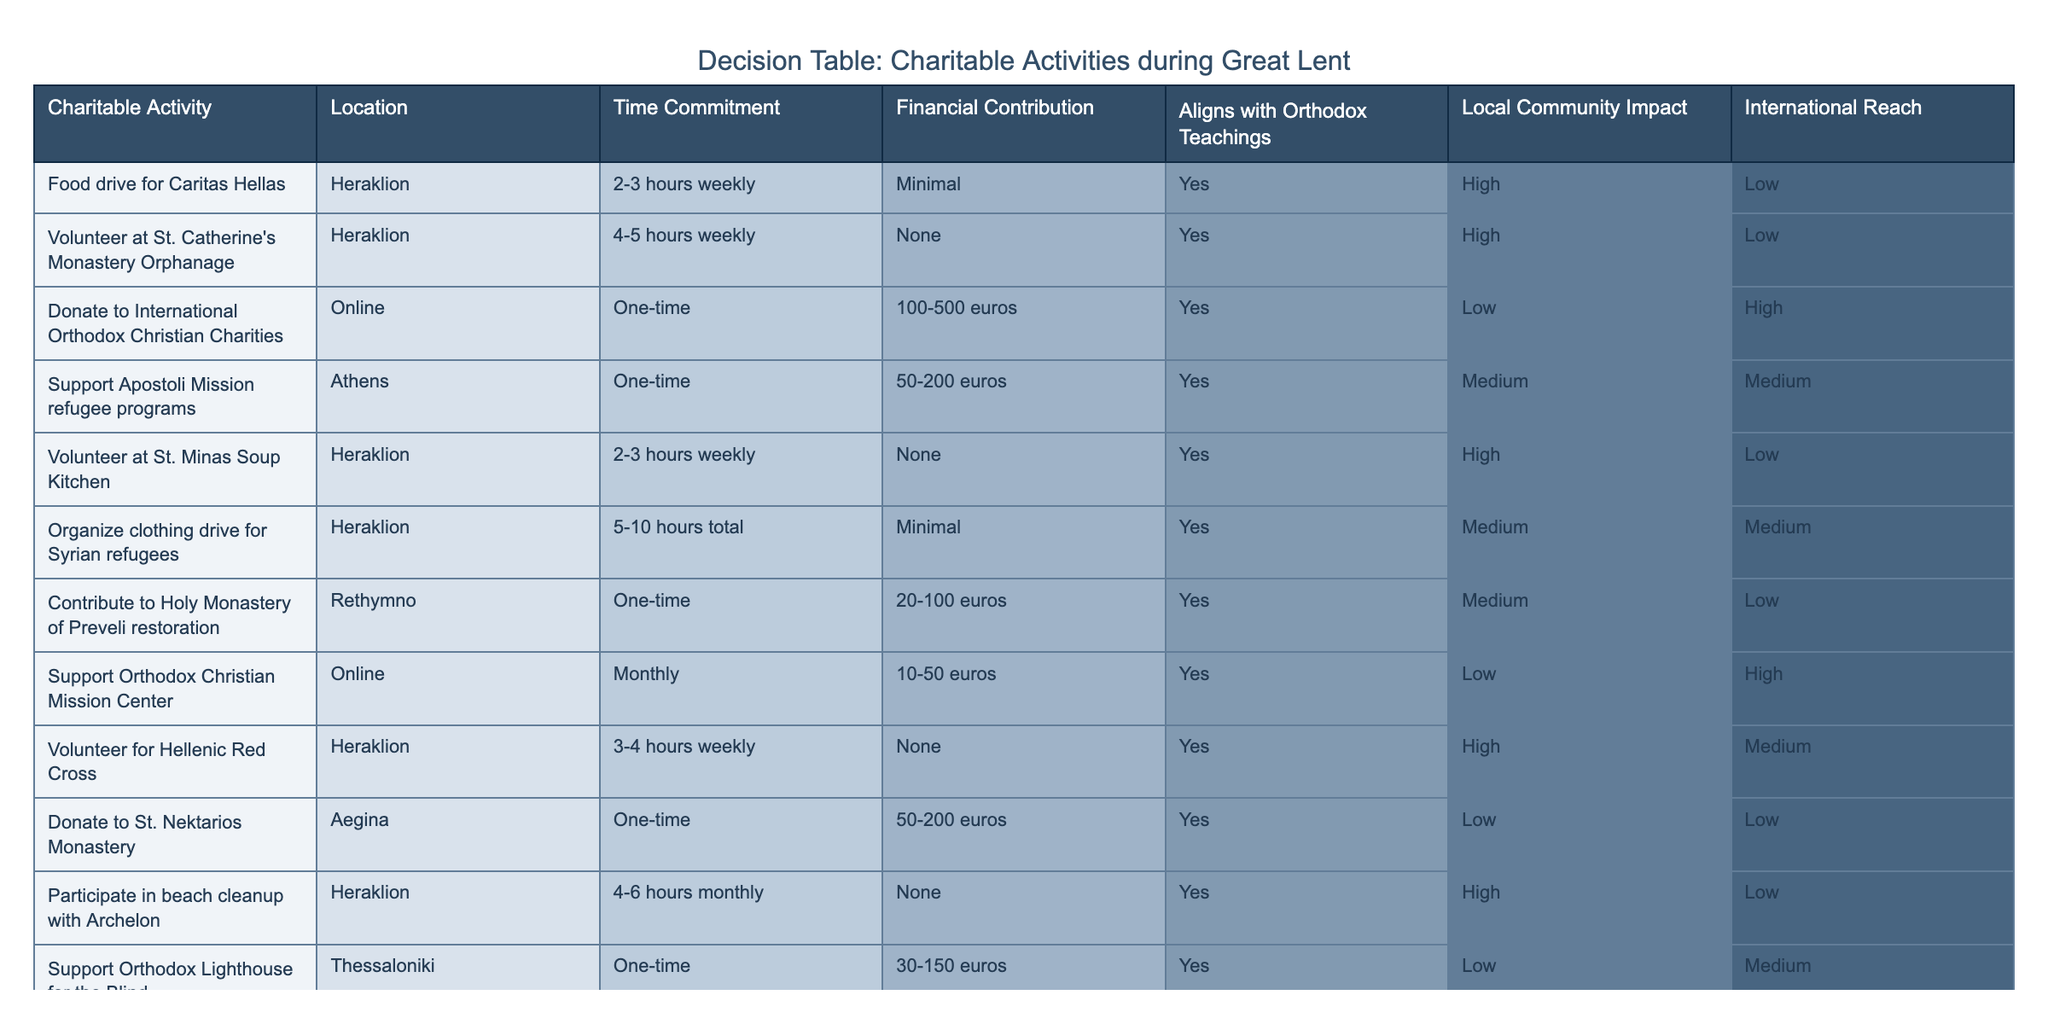What is the time commitment for volunteering at St. Catherine's Monastery Orphanage? The time commitment for this activity is stated as "4-5 hours weekly" in the table.
Answer: 4-5 hours weekly Which charitable activity requires the least financial contribution? The “Volunteer at St. Minas Soup Kitchen” and “Volunteer at St. Catherine's Monastery Orphanage” require no financial contribution, which is the minimum possible.
Answer: None How many activities have a local community impact rated as high? By reviewing the table, the activities with a high local community impact are: Food drive for Caritas Hellas, Volunteer at St. Catherine's Monastery Orphanage, Volunteer at St. Minas Soup Kitchen, and Volunteer for Hellenic Red Cross, totaling four activities.
Answer: 4 Is there any activity that aligns with Orthodox teachings but has low international reach? Yes, the "Support Orthodox Christian Mission Center" aligns with Orthodox teachings but has a low international reach, as indicated in the data.
Answer: Yes What is the average financial contribution for activities that have a high local community impact? The financial contributions for the activities with a high local community impact are: Food Drive (Minimal), Orphanage (None), Soup Kitchen (None), and Hellenic Red Cross (None). Assigning numerical values as follows: Minimal = 0, None = 0, we have 0 + 0 + 0 + 0 = 0, and there are 4 activities, so the average is 0/4 = 0.
Answer: 0 Which organization can I support if I want to make a one-time financial contribution between 50-200 euros? The activities that fit this criterion are "Support Apostoli Mission refugee programs" and "Donate to St. Nektarios Monastery," both marked for a one-time contribution of 50-200 euros.
Answer: 2 activities How many activities offer international reach? Looking through the table, there are 5 activities that indicate they provide international reach, which are: Donate to International Orthodox Christian Charities, Support Apostoli Mission refugee programs, Support Orthodox Christian Mission Center, Donate to Mount Athos Preservation Trust, and Support Orthodox Lighthouse for the Blind.
Answer: 5 What percentage of activities in the table require a time commitment of fewer than 5 hours weekly? There are 9 activities listed, of which 6 activities require fewer than 5 hours weekly. Calculating the percentage: (6/9) * 100 = 66.67%.
Answer: 66.67% 